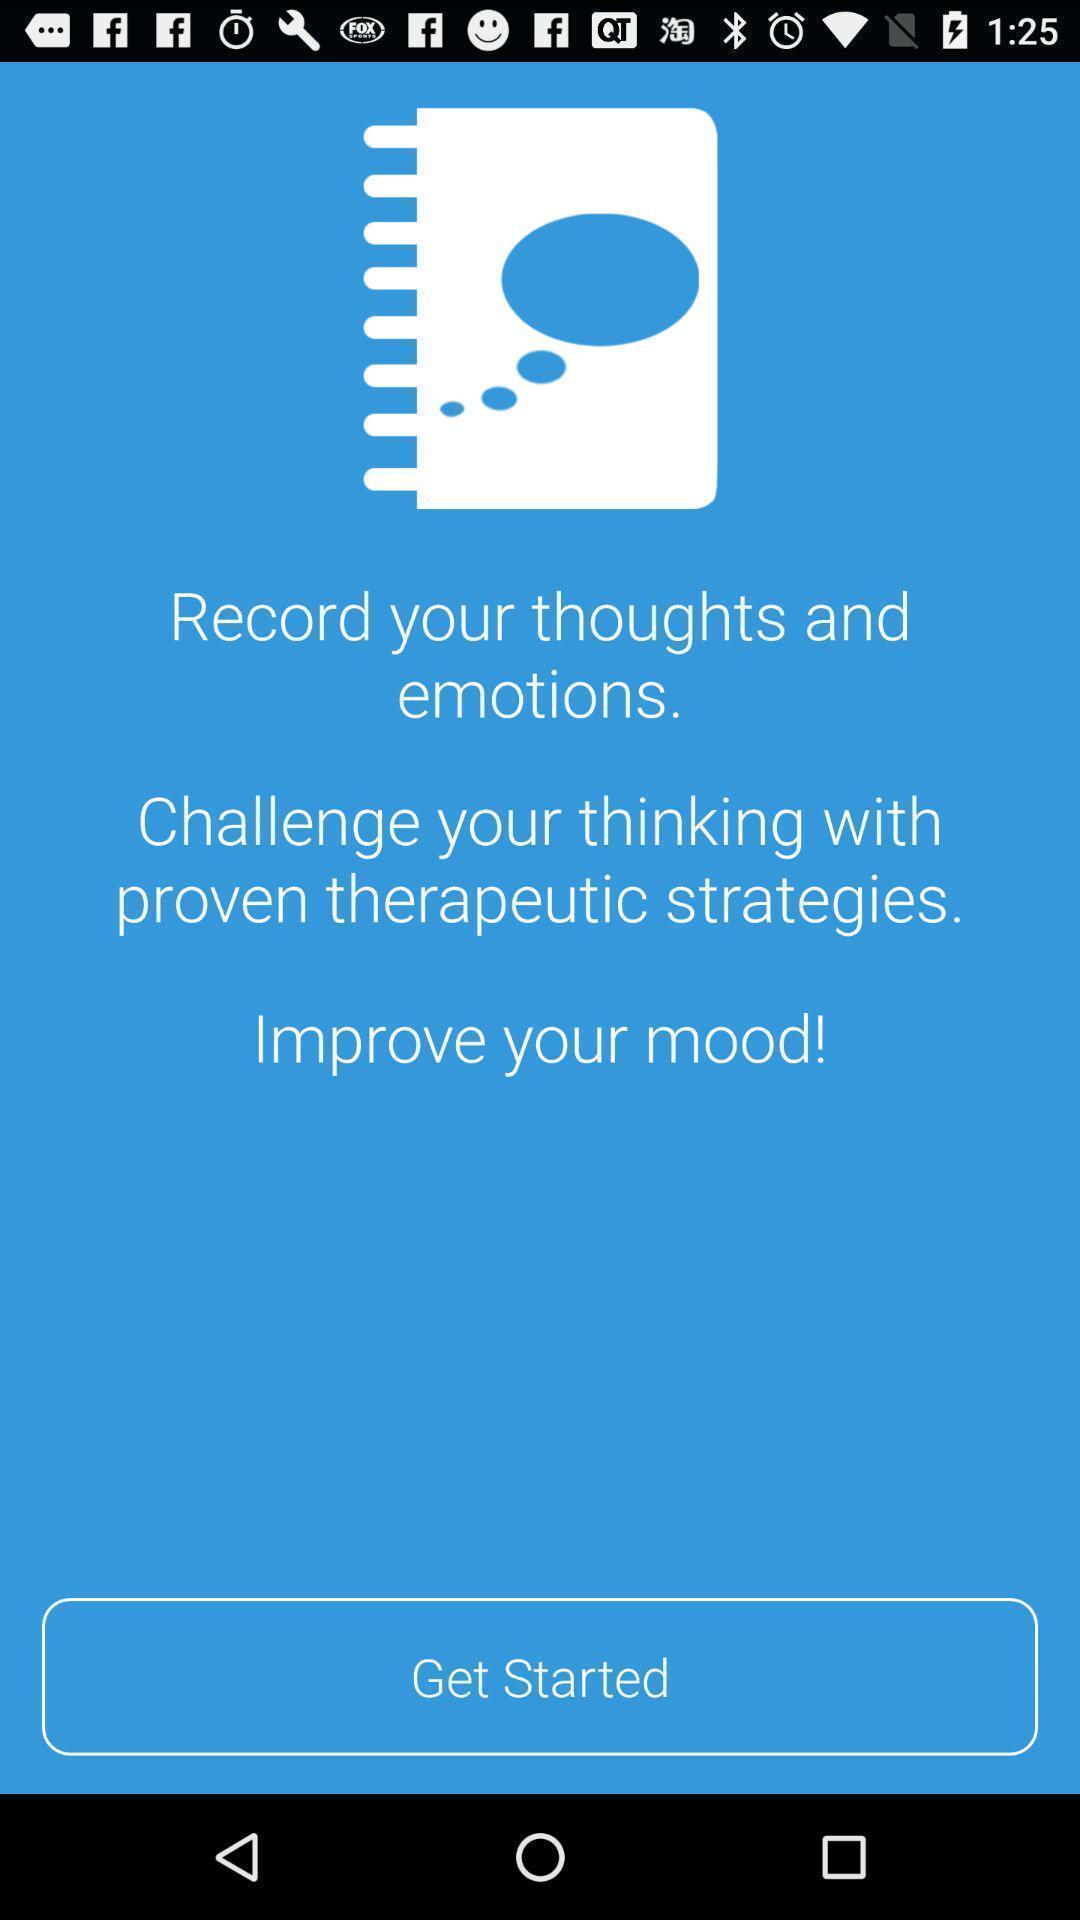Provide a textual representation of this image. Welcome page. 